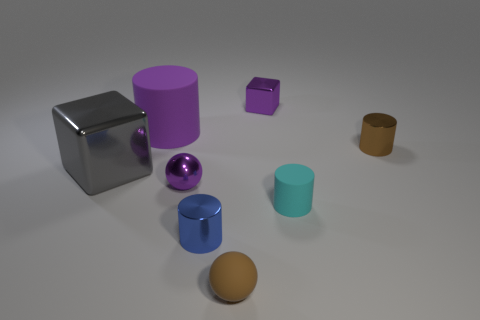What shape is the shiny thing that is both on the right side of the blue cylinder and in front of the large rubber thing?
Your answer should be very brief. Cylinder. There is a purple thing that is the same shape as the blue metal object; what is its size?
Give a very brief answer. Large. What number of cyan cylinders have the same material as the small brown sphere?
Provide a succinct answer. 1. Does the small metal block have the same color as the cylinder on the left side of the small purple sphere?
Give a very brief answer. Yes. Are there more tiny blocks than red cubes?
Provide a succinct answer. Yes. The tiny metal cube is what color?
Offer a terse response. Purple. Is the color of the tiny metal cylinder that is right of the small cyan object the same as the rubber sphere?
Your answer should be compact. Yes. There is a tiny sphere that is the same color as the large matte object; what material is it?
Give a very brief answer. Metal. What number of rubber things are the same color as the small matte cylinder?
Make the answer very short. 0. Does the tiny purple shiny thing that is on the left side of the rubber sphere have the same shape as the cyan thing?
Offer a terse response. No. 